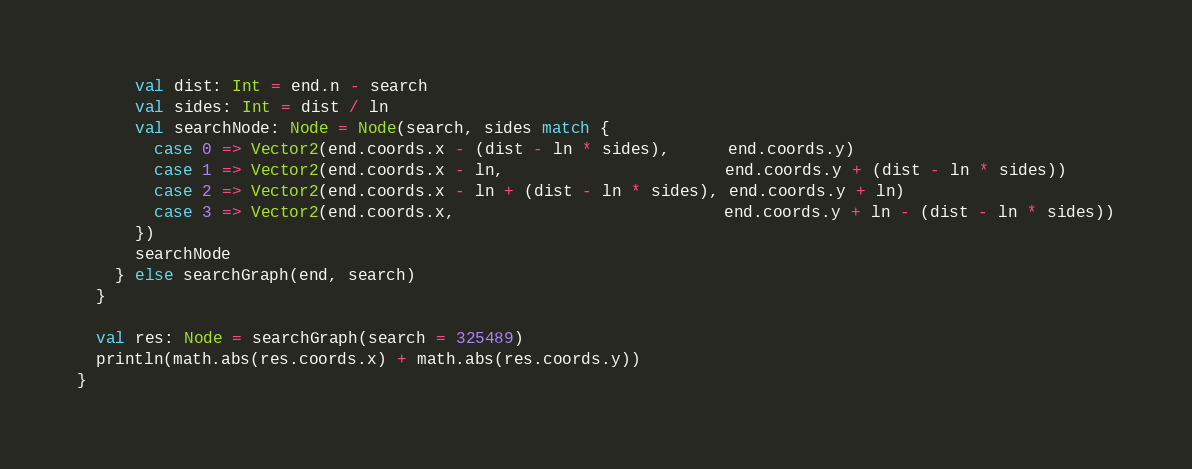<code> <loc_0><loc_0><loc_500><loc_500><_Scala_>      val dist: Int = end.n - search
      val sides: Int = dist / ln
      val searchNode: Node = Node(search, sides match {
        case 0 => Vector2(end.coords.x - (dist - ln * sides),      end.coords.y)
        case 1 => Vector2(end.coords.x - ln,                       end.coords.y + (dist - ln * sides))
        case 2 => Vector2(end.coords.x - ln + (dist - ln * sides), end.coords.y + ln)
        case 3 => Vector2(end.coords.x,                            end.coords.y + ln - (dist - ln * sides))
      })
      searchNode
    } else searchGraph(end, search)
  }

  val res: Node = searchGraph(search = 325489)
  println(math.abs(res.coords.x) + math.abs(res.coords.y))
}
</code> 